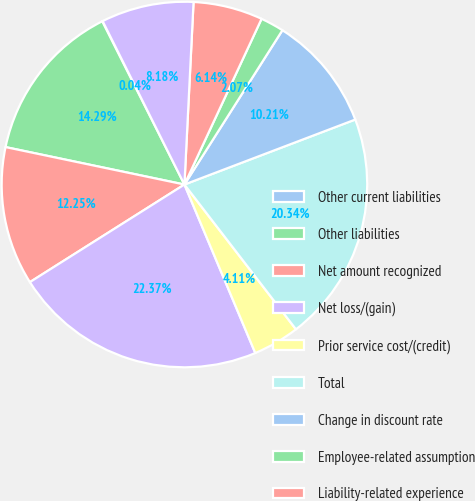Convert chart. <chart><loc_0><loc_0><loc_500><loc_500><pie_chart><fcel>Other current liabilities<fcel>Other liabilities<fcel>Net amount recognized<fcel>Net loss/(gain)<fcel>Prior service cost/(credit)<fcel>Total<fcel>Change in discount rate<fcel>Employee-related assumption<fcel>Liability-related experience<fcel>Actual asset return different<nl><fcel>0.04%<fcel>14.29%<fcel>12.25%<fcel>22.37%<fcel>4.11%<fcel>20.34%<fcel>10.21%<fcel>2.07%<fcel>6.14%<fcel>8.18%<nl></chart> 